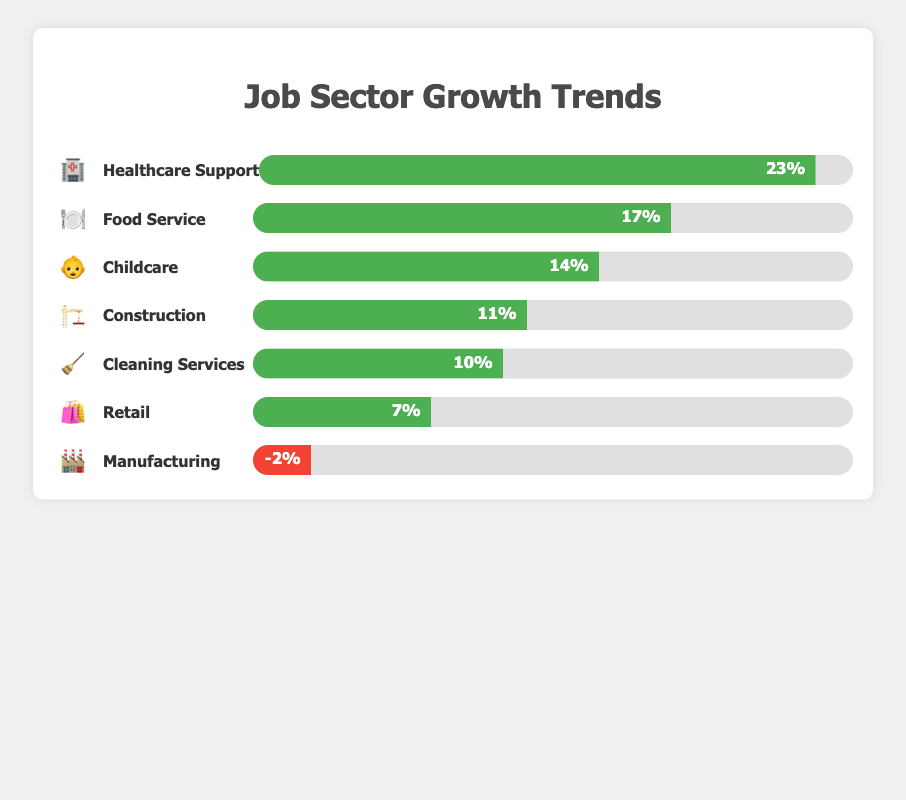Which job sector showed the highest growth? The Healthcare Support sector has the highest growth percentage at 23%, represented by the 🏥 emoji.
Answer: Healthcare Support Which job sectors showed negative growth? The Manufacturing sector is the only sector with negative growth at -2%, represented by the 🏭 emoji.
Answer: Manufacturing What's the combined growth rate of Healthcare Support and Food Service sectors? The Healthcare Support sector has a growth rate of 23%, and the Food Service sector has a growth rate of 17%. Adding these together: 23% + 17% = 40%.
Answer: 40% Which job sector has a growth rate closest to 10%? The Cleaning Services sector has a growth rate of 10%, represented by the 🧹 emoji.
Answer: Cleaning Services How does the growth rate of Childcare compare to that of Retail? The Childcare sector has a growth rate of 14%, and the Retail sector has a growth rate of 7%. 14% is higher than 7%.
Answer: Childcare has a higher growth rate What's the difference in growth between the highest growth sector and the lowest growth sector? The highest growth sector is Healthcare Support at 23%, and the lowest growth sector is Manufacturing at -2%. The difference is 23% - (-2%) = 25%.
Answer: 25% What's the average growth rate of all sectors? Sum all growth rates: 23% (Healthcare Support) + 17% (Food Service) + 7% (Retail) + 11% (Construction) + (-2%) (Manufacturing) + 14% (Childcare) + 10% (Cleaning Services) = 80%. There are 7 sectors, so the average growth rate is 80% / 7 ≈ 11.43%.
Answer: 11.43% In which sector does the growth rate exceed the average growth rate calculated? The average growth rate is approximately 11.43%. The Healthcare Support (23%), Food Service (17%), and Childcare (14%) sectors all exceed this average rate.
Answer: Healthcare Support, Food Service, Childcare 